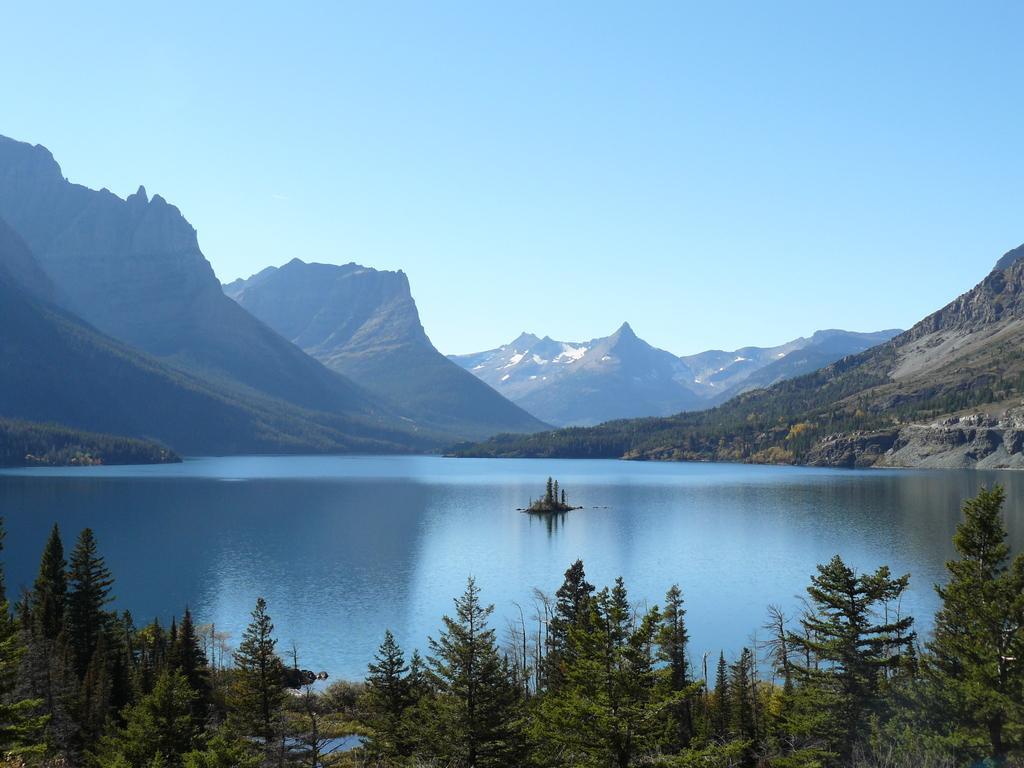In one or two sentences, can you explain what this image depicts? In this picture there is water in the center of the image and there are trees at the bottom side of the image, there are mountains in the background area of the image. 